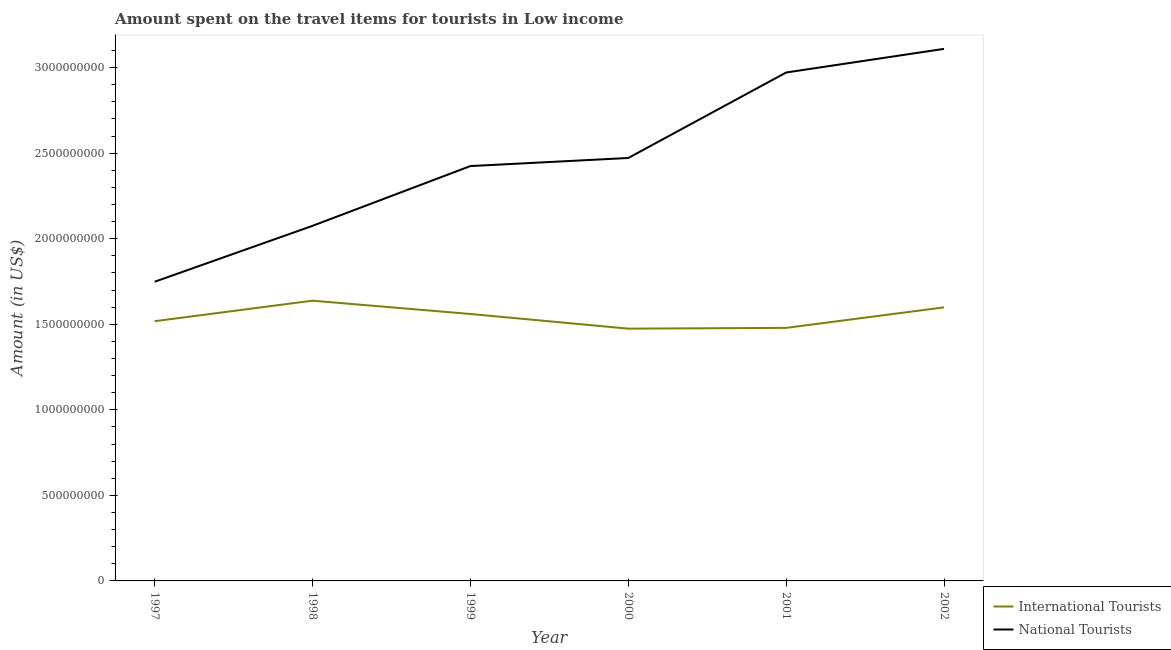Does the line corresponding to amount spent on travel items of international tourists intersect with the line corresponding to amount spent on travel items of national tourists?
Your answer should be compact. No. Is the number of lines equal to the number of legend labels?
Your answer should be very brief. Yes. What is the amount spent on travel items of national tourists in 2002?
Your answer should be very brief. 3.11e+09. Across all years, what is the maximum amount spent on travel items of national tourists?
Give a very brief answer. 3.11e+09. Across all years, what is the minimum amount spent on travel items of national tourists?
Offer a very short reply. 1.75e+09. In which year was the amount spent on travel items of international tourists maximum?
Your answer should be compact. 1998. What is the total amount spent on travel items of national tourists in the graph?
Make the answer very short. 1.48e+1. What is the difference between the amount spent on travel items of national tourists in 2000 and that in 2001?
Give a very brief answer. -5.00e+08. What is the difference between the amount spent on travel items of national tourists in 1999 and the amount spent on travel items of international tourists in 2000?
Give a very brief answer. 9.50e+08. What is the average amount spent on travel items of national tourists per year?
Your answer should be very brief. 2.47e+09. In the year 1997, what is the difference between the amount spent on travel items of international tourists and amount spent on travel items of national tourists?
Your answer should be very brief. -2.31e+08. What is the ratio of the amount spent on travel items of national tourists in 1998 to that in 2002?
Offer a terse response. 0.67. Is the amount spent on travel items of national tourists in 1999 less than that in 2001?
Provide a short and direct response. Yes. Is the difference between the amount spent on travel items of international tourists in 2000 and 2001 greater than the difference between the amount spent on travel items of national tourists in 2000 and 2001?
Ensure brevity in your answer.  Yes. What is the difference between the highest and the second highest amount spent on travel items of national tourists?
Your answer should be very brief. 1.38e+08. What is the difference between the highest and the lowest amount spent on travel items of international tourists?
Ensure brevity in your answer.  1.63e+08. In how many years, is the amount spent on travel items of national tourists greater than the average amount spent on travel items of national tourists taken over all years?
Give a very brief answer. 3. Is the amount spent on travel items of international tourists strictly greater than the amount spent on travel items of national tourists over the years?
Your response must be concise. No. How many lines are there?
Give a very brief answer. 2. How many years are there in the graph?
Provide a succinct answer. 6. Are the values on the major ticks of Y-axis written in scientific E-notation?
Offer a terse response. No. Does the graph contain any zero values?
Your answer should be very brief. No. Does the graph contain grids?
Keep it short and to the point. No. Where does the legend appear in the graph?
Your answer should be compact. Bottom right. How many legend labels are there?
Ensure brevity in your answer.  2. How are the legend labels stacked?
Your response must be concise. Vertical. What is the title of the graph?
Ensure brevity in your answer.  Amount spent on the travel items for tourists in Low income. What is the Amount (in US$) of International Tourists in 1997?
Provide a succinct answer. 1.52e+09. What is the Amount (in US$) of National Tourists in 1997?
Offer a very short reply. 1.75e+09. What is the Amount (in US$) of International Tourists in 1998?
Provide a short and direct response. 1.64e+09. What is the Amount (in US$) in National Tourists in 1998?
Offer a terse response. 2.08e+09. What is the Amount (in US$) of International Tourists in 1999?
Your answer should be very brief. 1.56e+09. What is the Amount (in US$) in National Tourists in 1999?
Give a very brief answer. 2.42e+09. What is the Amount (in US$) in International Tourists in 2000?
Offer a terse response. 1.47e+09. What is the Amount (in US$) in National Tourists in 2000?
Keep it short and to the point. 2.47e+09. What is the Amount (in US$) of International Tourists in 2001?
Your response must be concise. 1.48e+09. What is the Amount (in US$) in National Tourists in 2001?
Offer a terse response. 2.97e+09. What is the Amount (in US$) of International Tourists in 2002?
Your answer should be compact. 1.60e+09. What is the Amount (in US$) of National Tourists in 2002?
Offer a terse response. 3.11e+09. Across all years, what is the maximum Amount (in US$) in International Tourists?
Make the answer very short. 1.64e+09. Across all years, what is the maximum Amount (in US$) of National Tourists?
Offer a terse response. 3.11e+09. Across all years, what is the minimum Amount (in US$) of International Tourists?
Ensure brevity in your answer.  1.47e+09. Across all years, what is the minimum Amount (in US$) in National Tourists?
Offer a very short reply. 1.75e+09. What is the total Amount (in US$) in International Tourists in the graph?
Offer a very short reply. 9.27e+09. What is the total Amount (in US$) of National Tourists in the graph?
Your answer should be compact. 1.48e+1. What is the difference between the Amount (in US$) in International Tourists in 1997 and that in 1998?
Keep it short and to the point. -1.20e+08. What is the difference between the Amount (in US$) in National Tourists in 1997 and that in 1998?
Your response must be concise. -3.27e+08. What is the difference between the Amount (in US$) of International Tourists in 1997 and that in 1999?
Offer a very short reply. -4.21e+07. What is the difference between the Amount (in US$) of National Tourists in 1997 and that in 1999?
Give a very brief answer. -6.76e+08. What is the difference between the Amount (in US$) of International Tourists in 1997 and that in 2000?
Make the answer very short. 4.35e+07. What is the difference between the Amount (in US$) of National Tourists in 1997 and that in 2000?
Provide a short and direct response. -7.23e+08. What is the difference between the Amount (in US$) of International Tourists in 1997 and that in 2001?
Offer a very short reply. 3.90e+07. What is the difference between the Amount (in US$) of National Tourists in 1997 and that in 2001?
Offer a very short reply. -1.22e+09. What is the difference between the Amount (in US$) in International Tourists in 1997 and that in 2002?
Keep it short and to the point. -8.08e+07. What is the difference between the Amount (in US$) in National Tourists in 1997 and that in 2002?
Keep it short and to the point. -1.36e+09. What is the difference between the Amount (in US$) of International Tourists in 1998 and that in 1999?
Keep it short and to the point. 7.78e+07. What is the difference between the Amount (in US$) in National Tourists in 1998 and that in 1999?
Give a very brief answer. -3.49e+08. What is the difference between the Amount (in US$) in International Tourists in 1998 and that in 2000?
Provide a short and direct response. 1.63e+08. What is the difference between the Amount (in US$) of National Tourists in 1998 and that in 2000?
Your answer should be compact. -3.96e+08. What is the difference between the Amount (in US$) in International Tourists in 1998 and that in 2001?
Give a very brief answer. 1.59e+08. What is the difference between the Amount (in US$) of National Tourists in 1998 and that in 2001?
Provide a succinct answer. -8.96e+08. What is the difference between the Amount (in US$) of International Tourists in 1998 and that in 2002?
Provide a short and direct response. 3.91e+07. What is the difference between the Amount (in US$) in National Tourists in 1998 and that in 2002?
Offer a very short reply. -1.03e+09. What is the difference between the Amount (in US$) of International Tourists in 1999 and that in 2000?
Your response must be concise. 8.56e+07. What is the difference between the Amount (in US$) in National Tourists in 1999 and that in 2000?
Ensure brevity in your answer.  -4.72e+07. What is the difference between the Amount (in US$) of International Tourists in 1999 and that in 2001?
Keep it short and to the point. 8.11e+07. What is the difference between the Amount (in US$) in National Tourists in 1999 and that in 2001?
Keep it short and to the point. -5.47e+08. What is the difference between the Amount (in US$) in International Tourists in 1999 and that in 2002?
Provide a short and direct response. -3.87e+07. What is the difference between the Amount (in US$) in National Tourists in 1999 and that in 2002?
Offer a terse response. -6.85e+08. What is the difference between the Amount (in US$) in International Tourists in 2000 and that in 2001?
Offer a very short reply. -4.49e+06. What is the difference between the Amount (in US$) in National Tourists in 2000 and that in 2001?
Give a very brief answer. -5.00e+08. What is the difference between the Amount (in US$) in International Tourists in 2000 and that in 2002?
Ensure brevity in your answer.  -1.24e+08. What is the difference between the Amount (in US$) of National Tourists in 2000 and that in 2002?
Your response must be concise. -6.38e+08. What is the difference between the Amount (in US$) in International Tourists in 2001 and that in 2002?
Offer a very short reply. -1.20e+08. What is the difference between the Amount (in US$) in National Tourists in 2001 and that in 2002?
Ensure brevity in your answer.  -1.38e+08. What is the difference between the Amount (in US$) in International Tourists in 1997 and the Amount (in US$) in National Tourists in 1998?
Provide a short and direct response. -5.57e+08. What is the difference between the Amount (in US$) of International Tourists in 1997 and the Amount (in US$) of National Tourists in 1999?
Provide a short and direct response. -9.07e+08. What is the difference between the Amount (in US$) in International Tourists in 1997 and the Amount (in US$) in National Tourists in 2000?
Your answer should be very brief. -9.54e+08. What is the difference between the Amount (in US$) of International Tourists in 1997 and the Amount (in US$) of National Tourists in 2001?
Your answer should be compact. -1.45e+09. What is the difference between the Amount (in US$) of International Tourists in 1997 and the Amount (in US$) of National Tourists in 2002?
Your answer should be very brief. -1.59e+09. What is the difference between the Amount (in US$) in International Tourists in 1998 and the Amount (in US$) in National Tourists in 1999?
Your answer should be compact. -7.87e+08. What is the difference between the Amount (in US$) of International Tourists in 1998 and the Amount (in US$) of National Tourists in 2000?
Your answer should be compact. -8.34e+08. What is the difference between the Amount (in US$) in International Tourists in 1998 and the Amount (in US$) in National Tourists in 2001?
Offer a very short reply. -1.33e+09. What is the difference between the Amount (in US$) of International Tourists in 1998 and the Amount (in US$) of National Tourists in 2002?
Provide a succinct answer. -1.47e+09. What is the difference between the Amount (in US$) in International Tourists in 1999 and the Amount (in US$) in National Tourists in 2000?
Provide a succinct answer. -9.12e+08. What is the difference between the Amount (in US$) in International Tourists in 1999 and the Amount (in US$) in National Tourists in 2001?
Your answer should be compact. -1.41e+09. What is the difference between the Amount (in US$) of International Tourists in 1999 and the Amount (in US$) of National Tourists in 2002?
Ensure brevity in your answer.  -1.55e+09. What is the difference between the Amount (in US$) of International Tourists in 2000 and the Amount (in US$) of National Tourists in 2001?
Your response must be concise. -1.50e+09. What is the difference between the Amount (in US$) of International Tourists in 2000 and the Amount (in US$) of National Tourists in 2002?
Ensure brevity in your answer.  -1.64e+09. What is the difference between the Amount (in US$) of International Tourists in 2001 and the Amount (in US$) of National Tourists in 2002?
Your answer should be compact. -1.63e+09. What is the average Amount (in US$) in International Tourists per year?
Make the answer very short. 1.54e+09. What is the average Amount (in US$) of National Tourists per year?
Make the answer very short. 2.47e+09. In the year 1997, what is the difference between the Amount (in US$) in International Tourists and Amount (in US$) in National Tourists?
Your answer should be compact. -2.31e+08. In the year 1998, what is the difference between the Amount (in US$) of International Tourists and Amount (in US$) of National Tourists?
Offer a terse response. -4.37e+08. In the year 1999, what is the difference between the Amount (in US$) in International Tourists and Amount (in US$) in National Tourists?
Your answer should be very brief. -8.65e+08. In the year 2000, what is the difference between the Amount (in US$) in International Tourists and Amount (in US$) in National Tourists?
Offer a terse response. -9.97e+08. In the year 2001, what is the difference between the Amount (in US$) in International Tourists and Amount (in US$) in National Tourists?
Provide a succinct answer. -1.49e+09. In the year 2002, what is the difference between the Amount (in US$) of International Tourists and Amount (in US$) of National Tourists?
Your response must be concise. -1.51e+09. What is the ratio of the Amount (in US$) in International Tourists in 1997 to that in 1998?
Provide a short and direct response. 0.93. What is the ratio of the Amount (in US$) in National Tourists in 1997 to that in 1998?
Give a very brief answer. 0.84. What is the ratio of the Amount (in US$) in National Tourists in 1997 to that in 1999?
Your response must be concise. 0.72. What is the ratio of the Amount (in US$) in International Tourists in 1997 to that in 2000?
Your response must be concise. 1.03. What is the ratio of the Amount (in US$) in National Tourists in 1997 to that in 2000?
Your response must be concise. 0.71. What is the ratio of the Amount (in US$) of International Tourists in 1997 to that in 2001?
Give a very brief answer. 1.03. What is the ratio of the Amount (in US$) in National Tourists in 1997 to that in 2001?
Ensure brevity in your answer.  0.59. What is the ratio of the Amount (in US$) of International Tourists in 1997 to that in 2002?
Your response must be concise. 0.95. What is the ratio of the Amount (in US$) of National Tourists in 1997 to that in 2002?
Your response must be concise. 0.56. What is the ratio of the Amount (in US$) in International Tourists in 1998 to that in 1999?
Ensure brevity in your answer.  1.05. What is the ratio of the Amount (in US$) of National Tourists in 1998 to that in 1999?
Make the answer very short. 0.86. What is the ratio of the Amount (in US$) of International Tourists in 1998 to that in 2000?
Your answer should be very brief. 1.11. What is the ratio of the Amount (in US$) of National Tourists in 1998 to that in 2000?
Your answer should be very brief. 0.84. What is the ratio of the Amount (in US$) in International Tourists in 1998 to that in 2001?
Your answer should be compact. 1.11. What is the ratio of the Amount (in US$) of National Tourists in 1998 to that in 2001?
Provide a short and direct response. 0.7. What is the ratio of the Amount (in US$) of International Tourists in 1998 to that in 2002?
Make the answer very short. 1.02. What is the ratio of the Amount (in US$) in National Tourists in 1998 to that in 2002?
Your response must be concise. 0.67. What is the ratio of the Amount (in US$) of International Tourists in 1999 to that in 2000?
Give a very brief answer. 1.06. What is the ratio of the Amount (in US$) in National Tourists in 1999 to that in 2000?
Give a very brief answer. 0.98. What is the ratio of the Amount (in US$) in International Tourists in 1999 to that in 2001?
Your answer should be compact. 1.05. What is the ratio of the Amount (in US$) in National Tourists in 1999 to that in 2001?
Provide a succinct answer. 0.82. What is the ratio of the Amount (in US$) in International Tourists in 1999 to that in 2002?
Keep it short and to the point. 0.98. What is the ratio of the Amount (in US$) of National Tourists in 1999 to that in 2002?
Provide a succinct answer. 0.78. What is the ratio of the Amount (in US$) of National Tourists in 2000 to that in 2001?
Provide a succinct answer. 0.83. What is the ratio of the Amount (in US$) of International Tourists in 2000 to that in 2002?
Your answer should be compact. 0.92. What is the ratio of the Amount (in US$) of National Tourists in 2000 to that in 2002?
Provide a succinct answer. 0.79. What is the ratio of the Amount (in US$) in International Tourists in 2001 to that in 2002?
Provide a succinct answer. 0.93. What is the ratio of the Amount (in US$) in National Tourists in 2001 to that in 2002?
Offer a terse response. 0.96. What is the difference between the highest and the second highest Amount (in US$) in International Tourists?
Make the answer very short. 3.91e+07. What is the difference between the highest and the second highest Amount (in US$) of National Tourists?
Your response must be concise. 1.38e+08. What is the difference between the highest and the lowest Amount (in US$) in International Tourists?
Ensure brevity in your answer.  1.63e+08. What is the difference between the highest and the lowest Amount (in US$) in National Tourists?
Provide a succinct answer. 1.36e+09. 